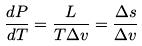<formula> <loc_0><loc_0><loc_500><loc_500>\frac { d P } { d T } = \frac { L } { T \Delta v } = \frac { \Delta s } { \Delta v }</formula> 